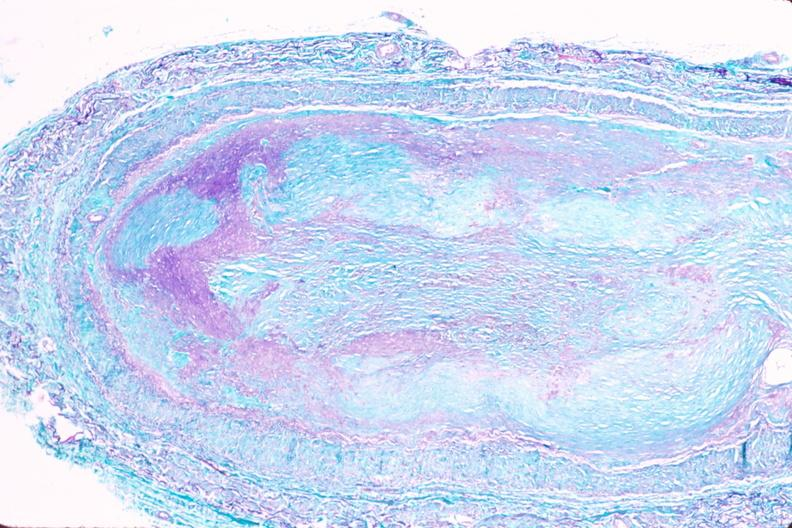what is present?
Answer the question using a single word or phrase. Cardiovascular 